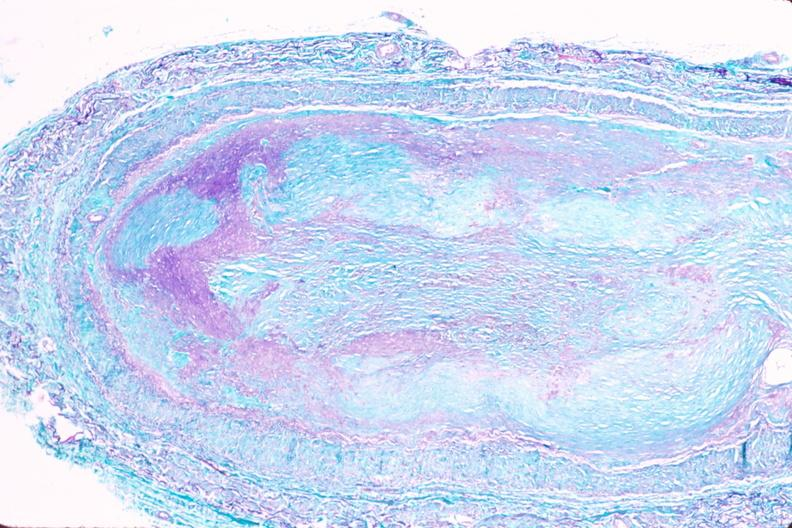what is present?
Answer the question using a single word or phrase. Cardiovascular 